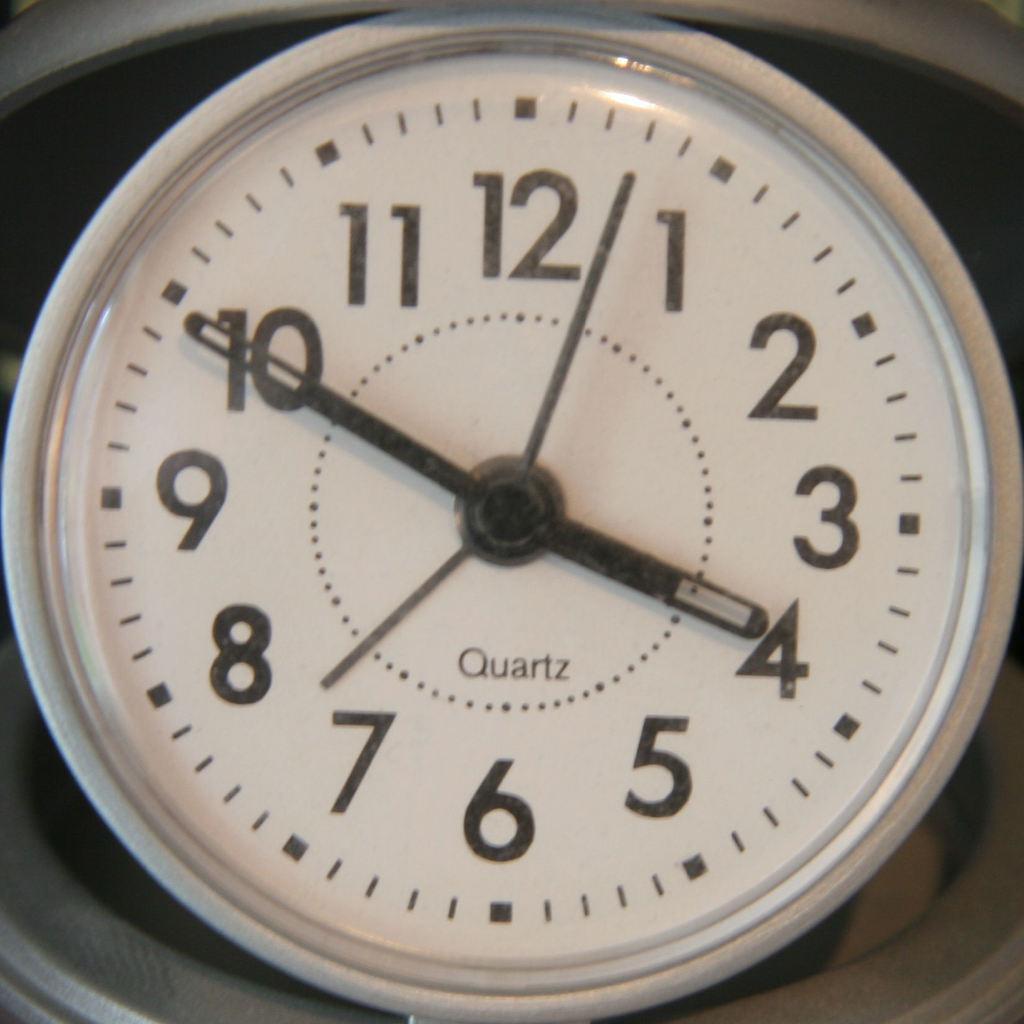<image>
Present a compact description of the photo's key features. A quartz clock that shows a time of 3:50. 